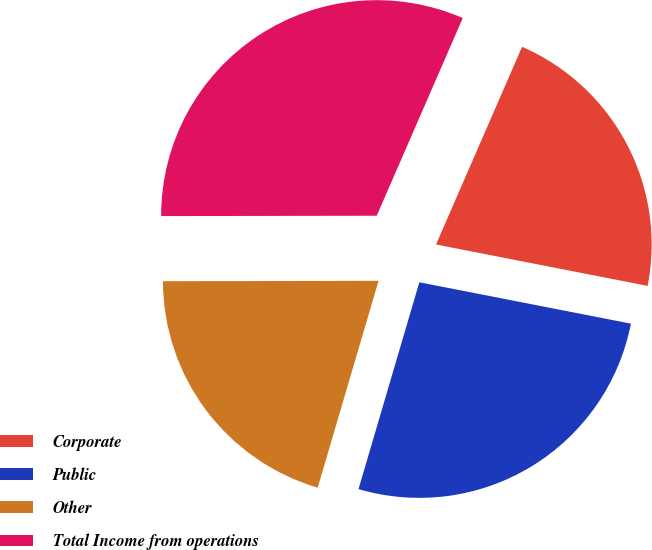Convert chart. <chart><loc_0><loc_0><loc_500><loc_500><pie_chart><fcel>Corporate<fcel>Public<fcel>Other<fcel>Total Income from operations<nl><fcel>21.54%<fcel>26.48%<fcel>20.42%<fcel>31.56%<nl></chart> 